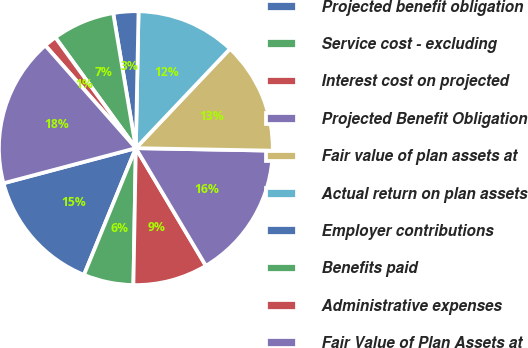Convert chart. <chart><loc_0><loc_0><loc_500><loc_500><pie_chart><fcel>Projected benefit obligation<fcel>Service cost - excluding<fcel>Interest cost on projected<fcel>Projected Benefit Obligation<fcel>Fair value of plan assets at<fcel>Actual return on plan assets<fcel>Employer contributions<fcel>Benefits paid<fcel>Administrative expenses<fcel>Fair Value of Plan Assets at<nl><fcel>14.69%<fcel>5.9%<fcel>8.83%<fcel>16.16%<fcel>13.22%<fcel>11.76%<fcel>2.96%<fcel>7.36%<fcel>1.5%<fcel>17.62%<nl></chart> 